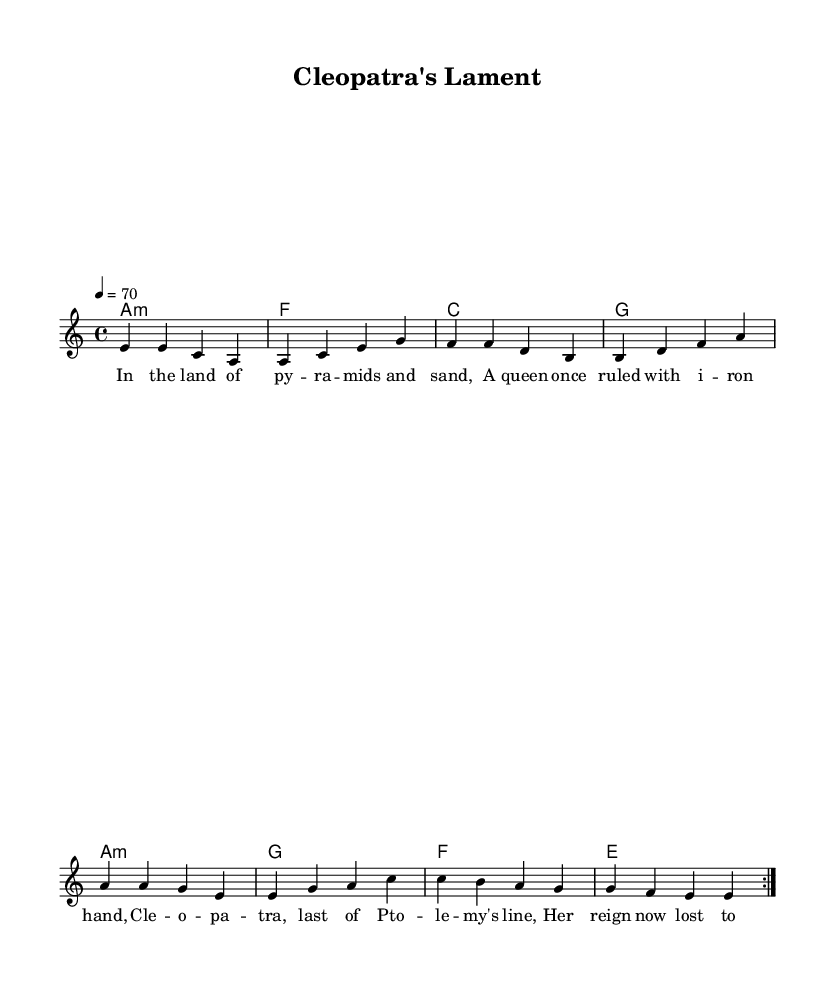What is the key signature of this music? The key signature shown in the music indicates that it is in A minor, which includes no sharps or flats. This can be inferred from the key indicated at the beginning of the score, which is a common feature in sheet music.
Answer: A minor What is the time signature of this music? The time signature is found at the beginning of the score, indicated as 4/4, which means there are four beats in a measure and a quarter note gets one beat. This is a standard time signature used frequently in various musical genres, including Rhythm and Blues.
Answer: 4/4 What is the tempo marking for this piece? The tempo marking appears at the beginning of the score, indicating that the piece should be played at a speed of 70 beats per minute. This information allows performers to grasp the intended speed of the music.
Answer: 70 How many verses are there in the lyrics? The lyrics section lists a verse followed by a chorus, and the verse section appears twice due to the repeat notation. This means there are two verses as indicated by the notation "repeat volta 2" in the melody line.
Answer: 1 What kind of musical form is used in this piece? This piece follows a common structure found in Rhythm and Blues, consisting of verses that are complemented by a chorus. The presence of repeated verses suggests a verse-chorus form typical of the genre.
Answer: Verse-Chorus What is the main theme conveyed in the lyrics? The lyrics reflect a historical narrative about Cleopatra, indicating themes of power and historical legacy. The references to North Africa's political life further underline the connection between the music and its historical context.
Answer: Cleopatra's lament 